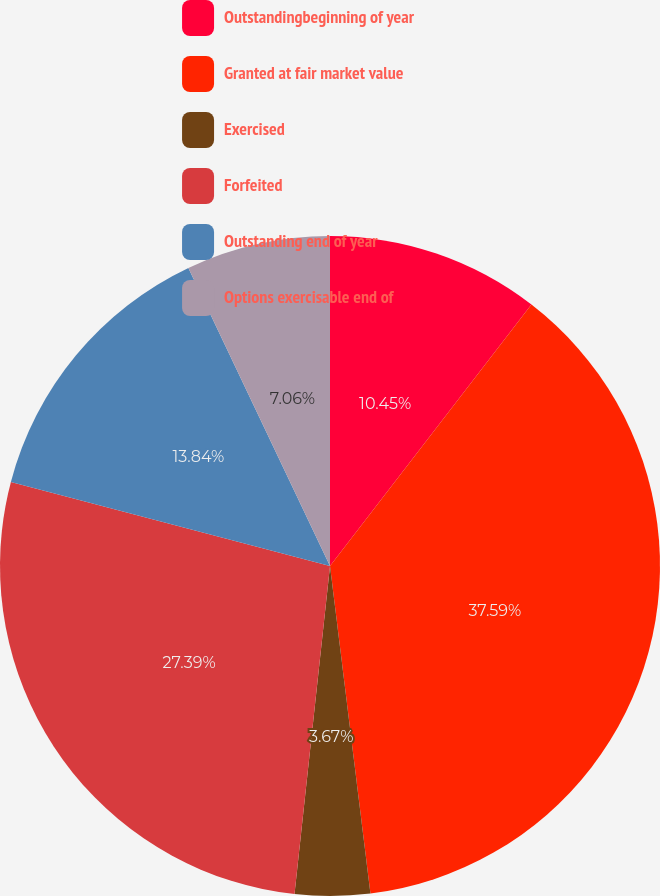<chart> <loc_0><loc_0><loc_500><loc_500><pie_chart><fcel>Outstandingbeginning of year<fcel>Granted at fair market value<fcel>Exercised<fcel>Forfeited<fcel>Outstanding end of year<fcel>Options exercisable end of<nl><fcel>10.45%<fcel>37.6%<fcel>3.67%<fcel>27.39%<fcel>13.84%<fcel>7.06%<nl></chart> 